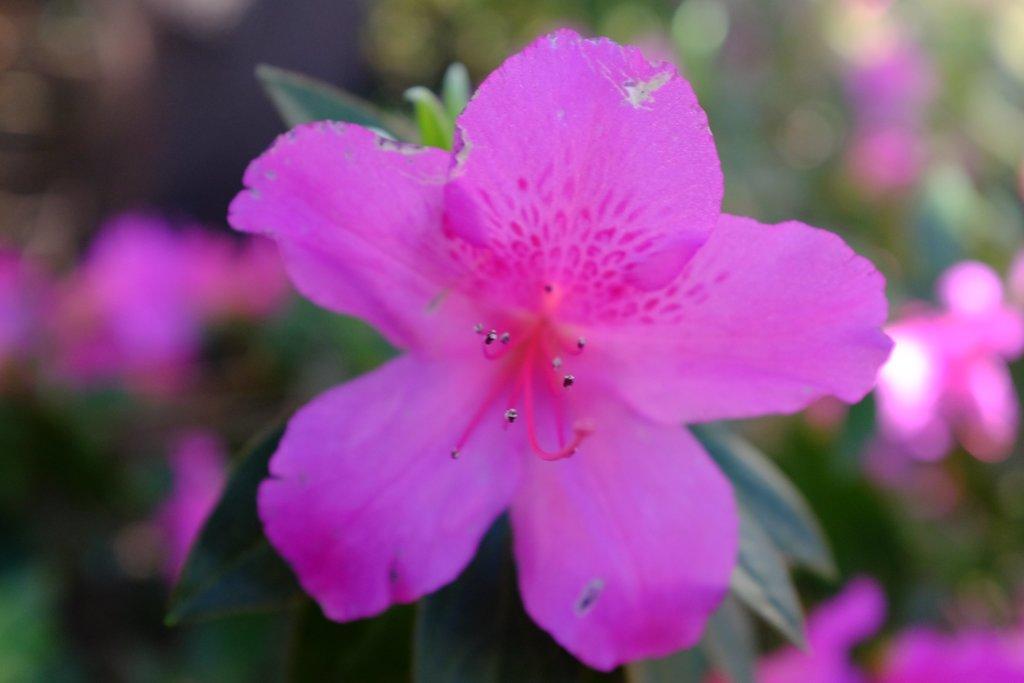Can you describe this image briefly? In this image we can see a flower on a plant. 